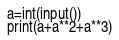<code> <loc_0><loc_0><loc_500><loc_500><_Python_>a=int(input())
print(a+a**2+a**3)</code> 